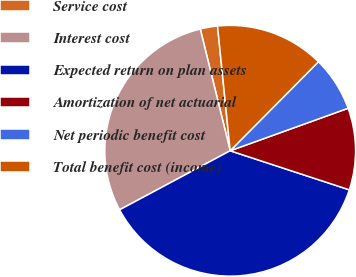Convert chart to OTSL. <chart><loc_0><loc_0><loc_500><loc_500><pie_chart><fcel>Service cost<fcel>Interest cost<fcel>Expected return on plan assets<fcel>Amortization of net actuarial<fcel>Net periodic benefit cost<fcel>Total benefit cost (income)<nl><fcel>2.23%<fcel>28.97%<fcel>37.15%<fcel>10.55%<fcel>7.06%<fcel>14.04%<nl></chart> 